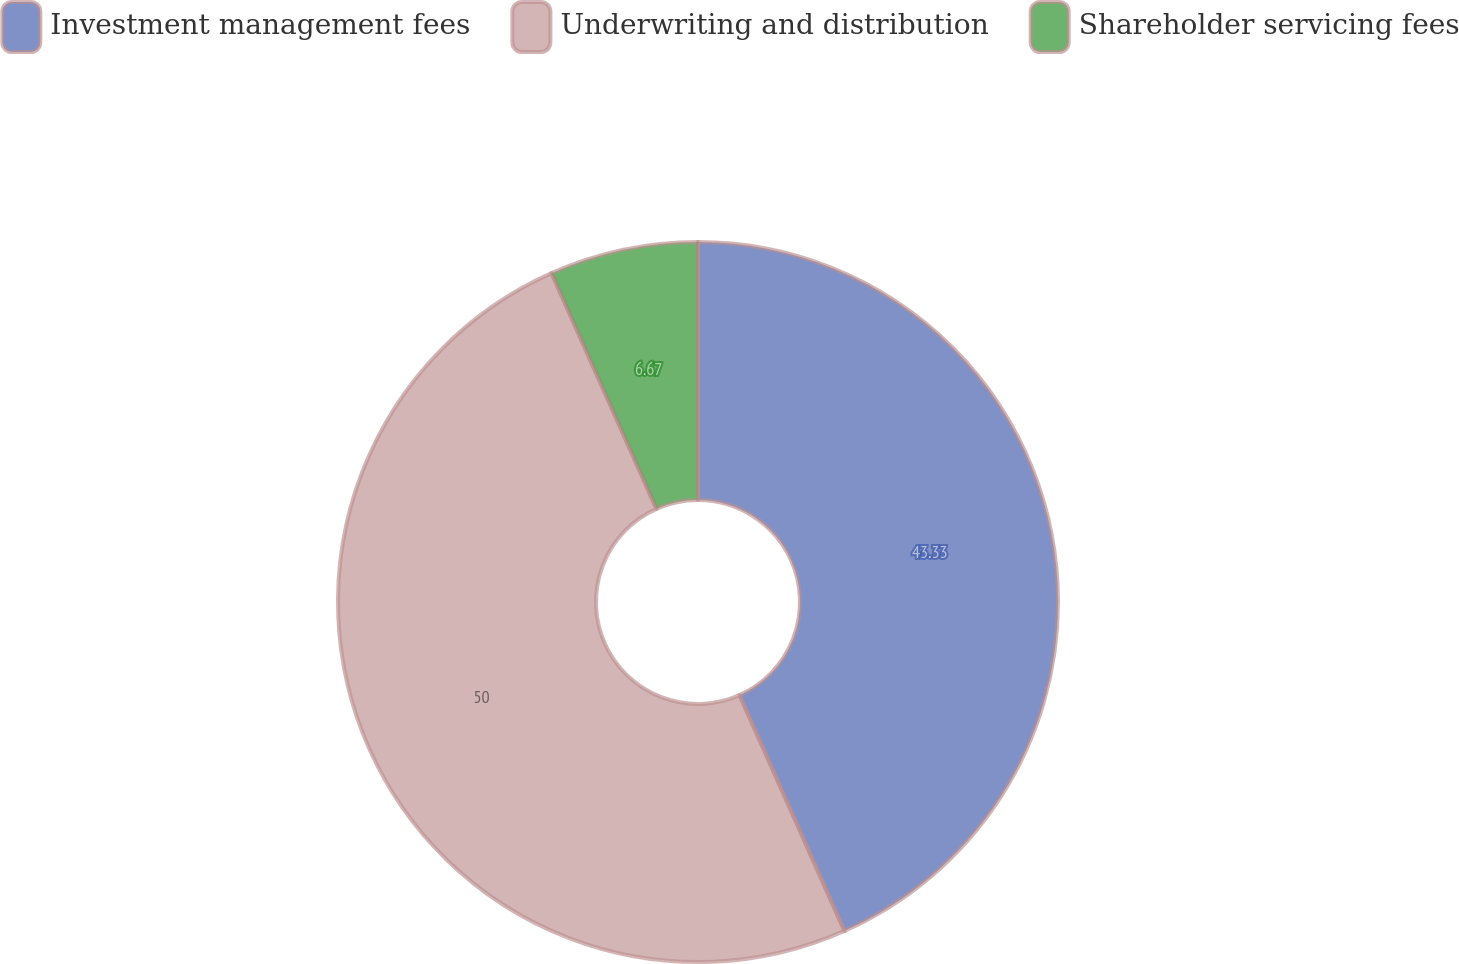<chart> <loc_0><loc_0><loc_500><loc_500><pie_chart><fcel>Investment management fees<fcel>Underwriting and distribution<fcel>Shareholder servicing fees<nl><fcel>43.33%<fcel>50.0%<fcel>6.67%<nl></chart> 